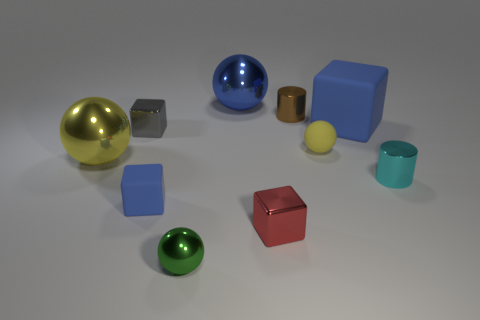Subtract 1 spheres. How many spheres are left? 3 Subtract all cylinders. How many objects are left? 8 Subtract all small brown cylinders. Subtract all large rubber cubes. How many objects are left? 8 Add 7 small cubes. How many small cubes are left? 10 Add 8 small red shiny objects. How many small red shiny objects exist? 9 Subtract 0 yellow blocks. How many objects are left? 10 